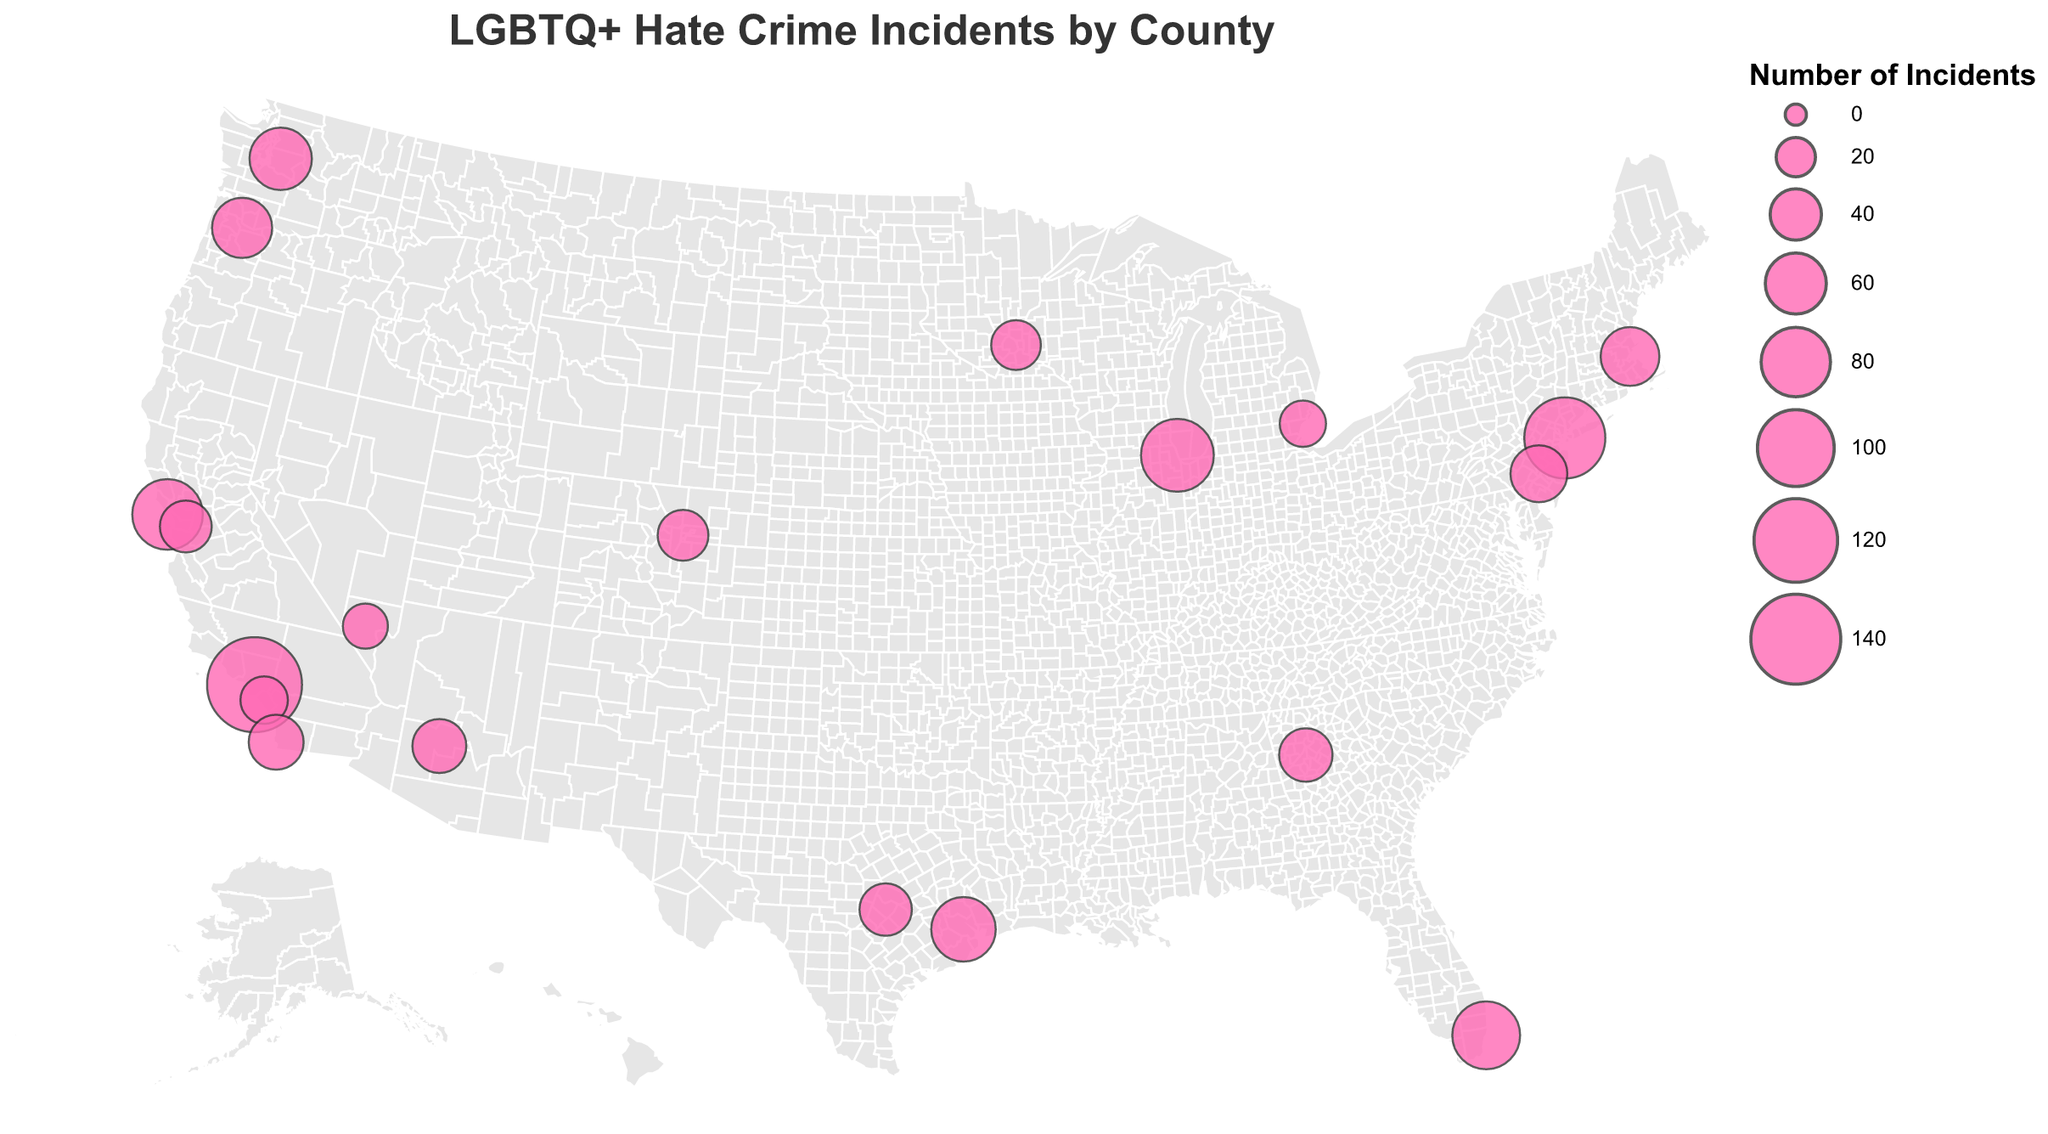what is the title of the figure? At the top of the figure, there's a text element that displays the title, which reads "LGBTQ+ Hate Crime Incidents by County."
Answer: LGBTQ+ Hate Crime Incidents by County How many counties have reported hate crime incidents against LGBTQ+ individuals in the figure? By counting the data points or circles on the map, we identify the total number of represented counties.
Answer: 20 Which county has recorded the highest number of hate crime incidents against LGBTQ+ individuals, and what is that number? Look for the largest circle on the map or check the tooltip for the highest value. Los Angeles County in California has the most incidents.
Answer: Los Angeles, 157 Which state has the most counties represented in the figure, and how many counties are there? Count the number of counties from each state displayed on the map. California has multiple counties: Los Angeles, San Francisco, Orange, Alameda, and San Diego.
Answer: California, 5 What is the total number of hate crime incidents reported in California? Sum the hate crime incidents for all counties in California: Los Angeles (157), San Francisco (83), Orange (33), Alameda (41), and San Diego (47). Total = 157 + 83 + 33 + 41 + 47.
Answer: 361 Which two counties have the closest number of hate crime incidents, and what are those numbers? Compare the hate crime incidents for each county; look for the smallest numerical difference. Miami-Dade, Florida (76) and Harris, Texas (68) are closest.
Answer: Miami-Dade: 76, Harris: 68 What is the average number of hate crime incidents across all the counties shown in the figure? Sum all the hate crime incidents from the counties and divide by the total number of counties: (157 + 89 + 112 + 76 + 63 + 42 + 58 + 37 + 51 + 83 + 29 + 45 + 68 + 33 + 41 + 55 + 47 + 39 + 31 + 44) / 20.
Answer: 58.75 Which state's represented counties have the highest and lowest number of hate crime incidents, and what are those numbers? Compare the highest and lowest values for counties within the same state. California has the highest (Los Angeles: 157) and lowest (Orange: 33).
Answer: Highest: Los Angeles, 157; Lowest: Orange, 33 What is the total number of hate crime incidents reported in Texas across its counties shown in the figure? Sum the hate crime incidents for all counties in Texas: Travis (42) and Harris (68). Total = 42 + 68.
Answer: 110 